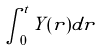Convert formula to latex. <formula><loc_0><loc_0><loc_500><loc_500>\int _ { 0 } ^ { t } Y ( r ) d r</formula> 